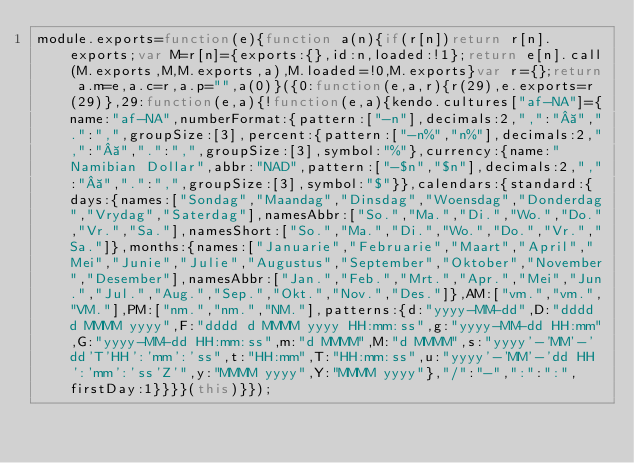<code> <loc_0><loc_0><loc_500><loc_500><_JavaScript_>module.exports=function(e){function a(n){if(r[n])return r[n].exports;var M=r[n]={exports:{},id:n,loaded:!1};return e[n].call(M.exports,M,M.exports,a),M.loaded=!0,M.exports}var r={};return a.m=e,a.c=r,a.p="",a(0)}({0:function(e,a,r){r(29),e.exports=r(29)},29:function(e,a){!function(e,a){kendo.cultures["af-NA"]={name:"af-NA",numberFormat:{pattern:["-n"],decimals:2,",":" ",".":",",groupSize:[3],percent:{pattern:["-n%","n%"],decimals:2,",":" ",".":",",groupSize:[3],symbol:"%"},currency:{name:"Namibian Dollar",abbr:"NAD",pattern:["-$n","$n"],decimals:2,",":" ",".":",",groupSize:[3],symbol:"$"}},calendars:{standard:{days:{names:["Sondag","Maandag","Dinsdag","Woensdag","Donderdag","Vrydag","Saterdag"],namesAbbr:["So.","Ma.","Di.","Wo.","Do.","Vr.","Sa."],namesShort:["So.","Ma.","Di.","Wo.","Do.","Vr.","Sa."]},months:{names:["Januarie","Februarie","Maart","April","Mei","Junie","Julie","Augustus","September","Oktober","November","Desember"],namesAbbr:["Jan.","Feb.","Mrt.","Apr.","Mei","Jun.","Jul.","Aug.","Sep.","Okt.","Nov.","Des."]},AM:["vm.","vm.","VM."],PM:["nm.","nm.","NM."],patterns:{d:"yyyy-MM-dd",D:"dddd d MMMM yyyy",F:"dddd d MMMM yyyy HH:mm:ss",g:"yyyy-MM-dd HH:mm",G:"yyyy-MM-dd HH:mm:ss",m:"d MMMM",M:"d MMMM",s:"yyyy'-'MM'-'dd'T'HH':'mm':'ss",t:"HH:mm",T:"HH:mm:ss",u:"yyyy'-'MM'-'dd HH':'mm':'ss'Z'",y:"MMMM yyyy",Y:"MMMM yyyy"},"/":"-",":":":",firstDay:1}}}}(this)}});</code> 